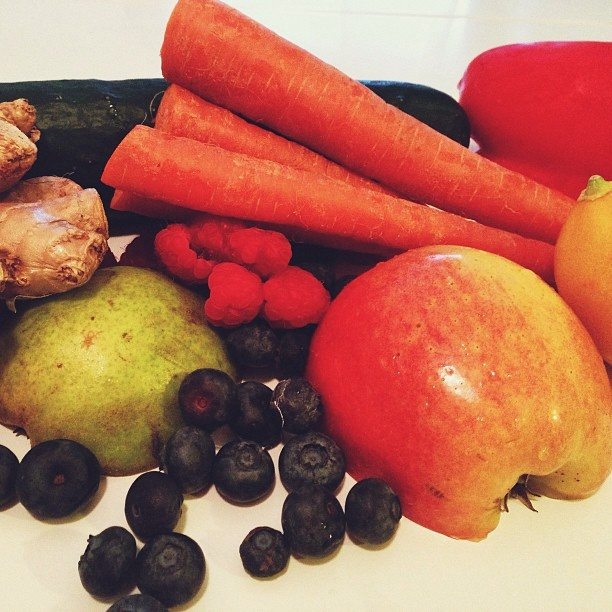Describe the objects in this image and their specific colors. I can see apple in beige, orange, red, and salmon tones, carrot in beige, salmon, red, and brown tones, carrot in beige, salmon, red, and brown tones, carrot in beige, red, salmon, and brown tones, and orange in beige, red, orange, and brown tones in this image. 